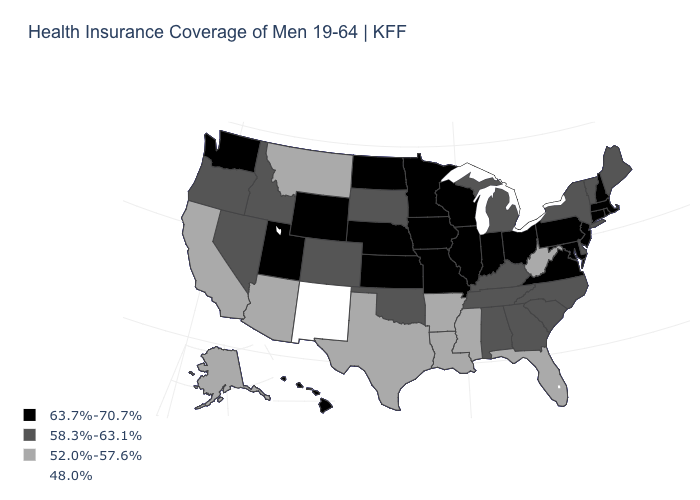Among the states that border Montana , which have the lowest value?
Short answer required. Idaho, South Dakota. Is the legend a continuous bar?
Concise answer only. No. What is the value of Connecticut?
Write a very short answer. 63.7%-70.7%. Name the states that have a value in the range 58.3%-63.1%?
Be succinct. Alabama, Colorado, Delaware, Georgia, Idaho, Kentucky, Maine, Michigan, Nevada, New York, North Carolina, Oklahoma, Oregon, South Carolina, South Dakota, Tennessee, Vermont. Name the states that have a value in the range 48.0%?
Answer briefly. New Mexico. Name the states that have a value in the range 52.0%-57.6%?
Be succinct. Alaska, Arizona, Arkansas, California, Florida, Louisiana, Mississippi, Montana, Texas, West Virginia. Does the map have missing data?
Keep it brief. No. Name the states that have a value in the range 58.3%-63.1%?
Give a very brief answer. Alabama, Colorado, Delaware, Georgia, Idaho, Kentucky, Maine, Michigan, Nevada, New York, North Carolina, Oklahoma, Oregon, South Carolina, South Dakota, Tennessee, Vermont. Name the states that have a value in the range 58.3%-63.1%?
Write a very short answer. Alabama, Colorado, Delaware, Georgia, Idaho, Kentucky, Maine, Michigan, Nevada, New York, North Carolina, Oklahoma, Oregon, South Carolina, South Dakota, Tennessee, Vermont. Does the first symbol in the legend represent the smallest category?
Keep it brief. No. Among the states that border Ohio , which have the lowest value?
Keep it brief. West Virginia. Does Arkansas have the lowest value in the South?
Keep it brief. Yes. What is the value of Maryland?
Be succinct. 63.7%-70.7%. Does Maryland have a higher value than Minnesota?
Quick response, please. No. What is the value of Alabama?
Concise answer only. 58.3%-63.1%. 